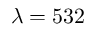<formula> <loc_0><loc_0><loc_500><loc_500>\lambda = 5 3 2</formula> 